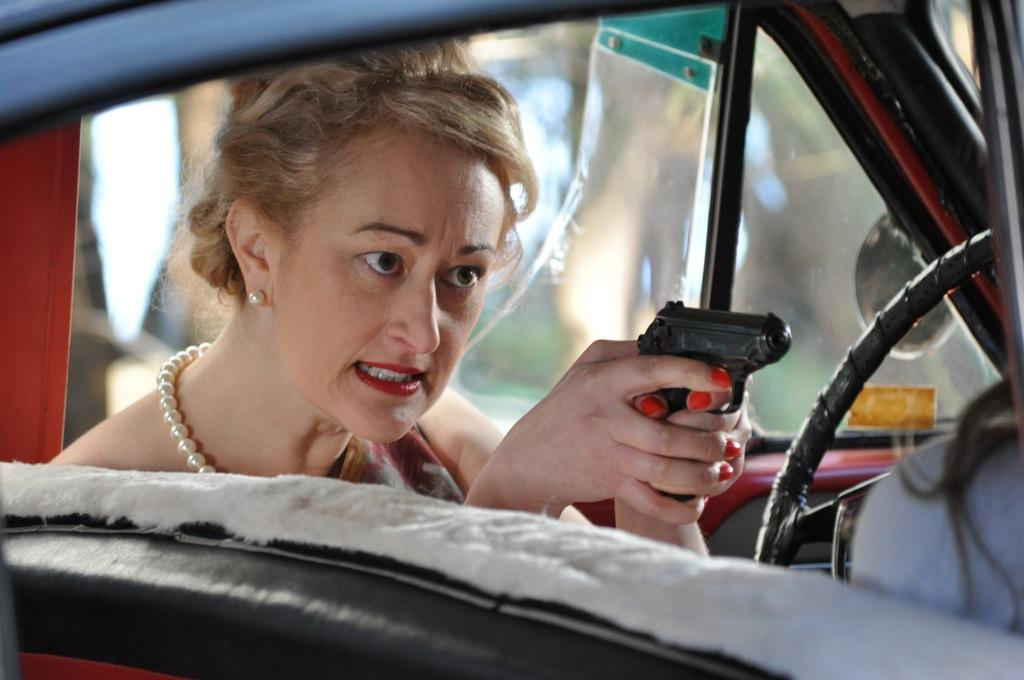Who is the main subject in the image? There is a lady in the image. What is the lady holding in her hand? The lady is holding a pistol in her hand. What is the lady's position in the image? The lady appears to be sitting in a vehicle. Can you describe the background of the image? The background of the image is blurred. How many chickens can be seen in the image? There are no chickens present in the image. What type of home is visible in the background of the image? There is no home visible in the image; the background is blurred. 